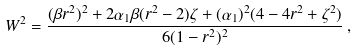<formula> <loc_0><loc_0><loc_500><loc_500>W ^ { 2 } = \frac { ( \beta r ^ { 2 } ) ^ { 2 } + 2 \alpha _ { 1 } \beta ( r ^ { 2 } - 2 ) \zeta + ( \alpha _ { 1 } ) ^ { 2 } ( 4 - 4 r ^ { 2 } + \zeta ^ { 2 } ) } { 6 ( 1 - r ^ { 2 } ) ^ { 2 } } \, ,</formula> 